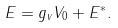<formula> <loc_0><loc_0><loc_500><loc_500>E = g _ { v } V _ { 0 } + E ^ { \ast } .</formula> 